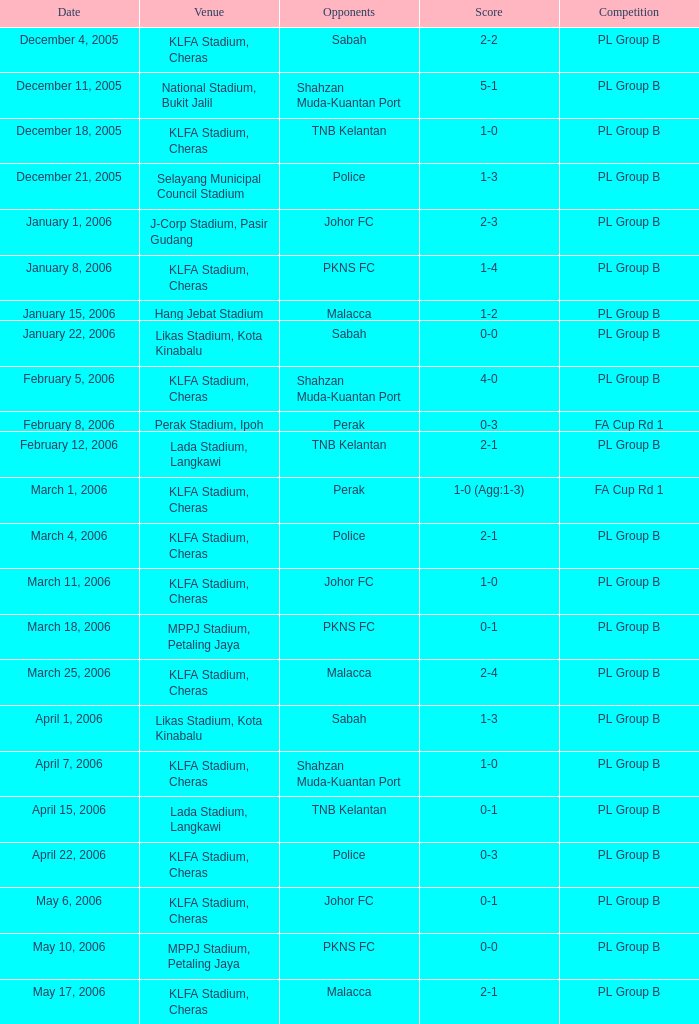What is the score for opponents of pkns fc on january 8, 2006? 1-4. 